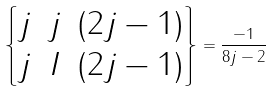<formula> <loc_0><loc_0><loc_500><loc_500>\begin{Bmatrix} j & j & ( 2 j - 1 ) \\ j & I & ( 2 j - 1 ) \end{Bmatrix} = \frac { - 1 } { 8 j - 2 }</formula> 